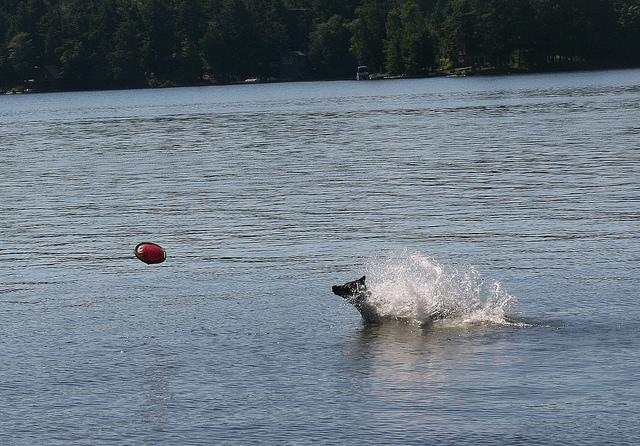What is the dog going to do next?
Write a very short answer. Jump. Is the dog splashing water behind it?
Be succinct. Yes. Is this a dog trying to catch a frisbee?
Be succinct. Yes. What color is the frisbee?
Concise answer only. Red. 